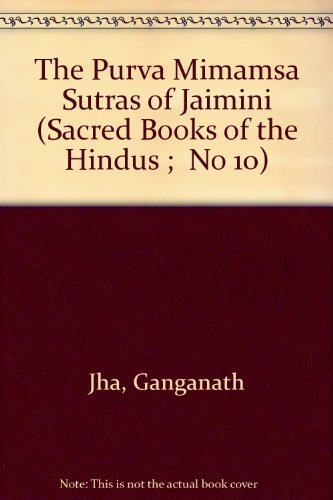Is this book related to Religion & Spirituality? Yes, indeed. This book's focus on the Mimamsa Sutras ties it directly to the Hindu spiritual and religious tradition, offering insight into its philosophical underpinnings. 